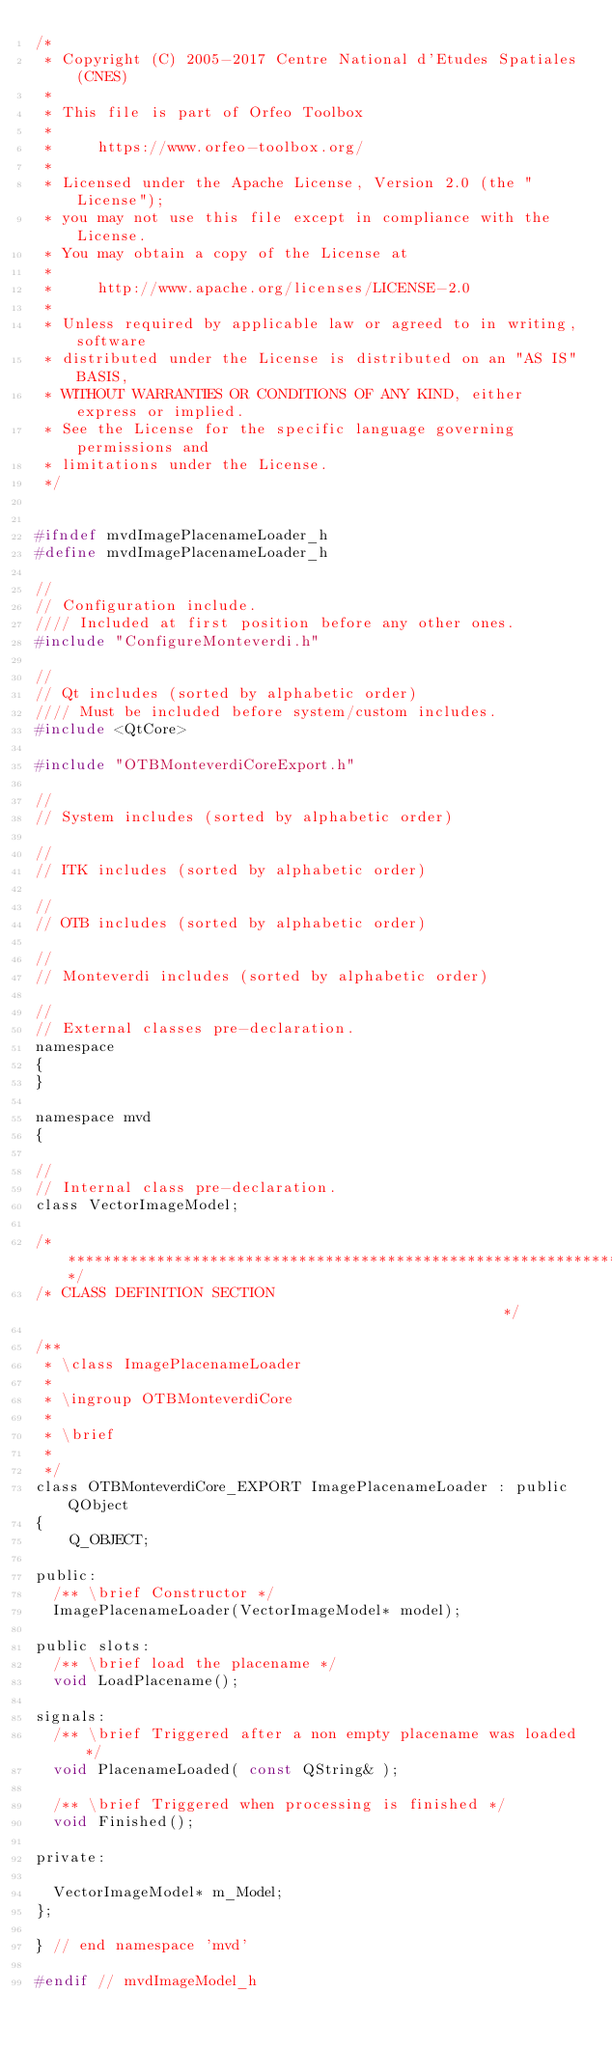<code> <loc_0><loc_0><loc_500><loc_500><_C_>/*
 * Copyright (C) 2005-2017 Centre National d'Etudes Spatiales (CNES)
 *
 * This file is part of Orfeo Toolbox
 *
 *     https://www.orfeo-toolbox.org/
 *
 * Licensed under the Apache License, Version 2.0 (the "License");
 * you may not use this file except in compliance with the License.
 * You may obtain a copy of the License at
 *
 *     http://www.apache.org/licenses/LICENSE-2.0
 *
 * Unless required by applicable law or agreed to in writing, software
 * distributed under the License is distributed on an "AS IS" BASIS,
 * WITHOUT WARRANTIES OR CONDITIONS OF ANY KIND, either express or implied.
 * See the License for the specific language governing permissions and
 * limitations under the License.
 */


#ifndef mvdImagePlacenameLoader_h
#define mvdImagePlacenameLoader_h

//
// Configuration include.
//// Included at first position before any other ones.
#include "ConfigureMonteverdi.h"

//
// Qt includes (sorted by alphabetic order)
//// Must be included before system/custom includes.
#include <QtCore>

#include "OTBMonteverdiCoreExport.h"

//
// System includes (sorted by alphabetic order)

//
// ITK includes (sorted by alphabetic order)

//
// OTB includes (sorted by alphabetic order)

//
// Monteverdi includes (sorted by alphabetic order)

//
// External classes pre-declaration.
namespace
{
}

namespace mvd
{

//
// Internal class pre-declaration.
class VectorImageModel;

/*****************************************************************************/
/* CLASS DEFINITION SECTION                                                  */

/**
 * \class ImagePlacenameLoader
 *
 * \ingroup OTBMonteverdiCore
 *
 * \brief
 *
 */
class OTBMonteverdiCore_EXPORT ImagePlacenameLoader : public QObject
{
    Q_OBJECT;

public:
  /** \brief Constructor */
  ImagePlacenameLoader(VectorImageModel* model);

public slots:
  /** \brief load the placename */
  void LoadPlacename();

signals:
  /** \brief Triggered after a non empty placename was loaded */
  void PlacenameLoaded( const QString& );

  /** \brief Triggered when processing is finished */
  void Finished();

private:

  VectorImageModel* m_Model;
};

} // end namespace 'mvd'

#endif // mvdImageModel_h
</code> 